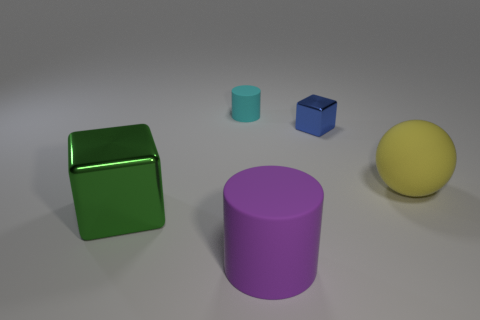Add 4 small matte cylinders. How many objects exist? 9 Subtract all cylinders. How many objects are left? 3 Subtract 1 yellow balls. How many objects are left? 4 Subtract all matte spheres. Subtract all blue shiny blocks. How many objects are left? 3 Add 2 blue shiny objects. How many blue shiny objects are left? 3 Add 1 blue metallic cylinders. How many blue metallic cylinders exist? 1 